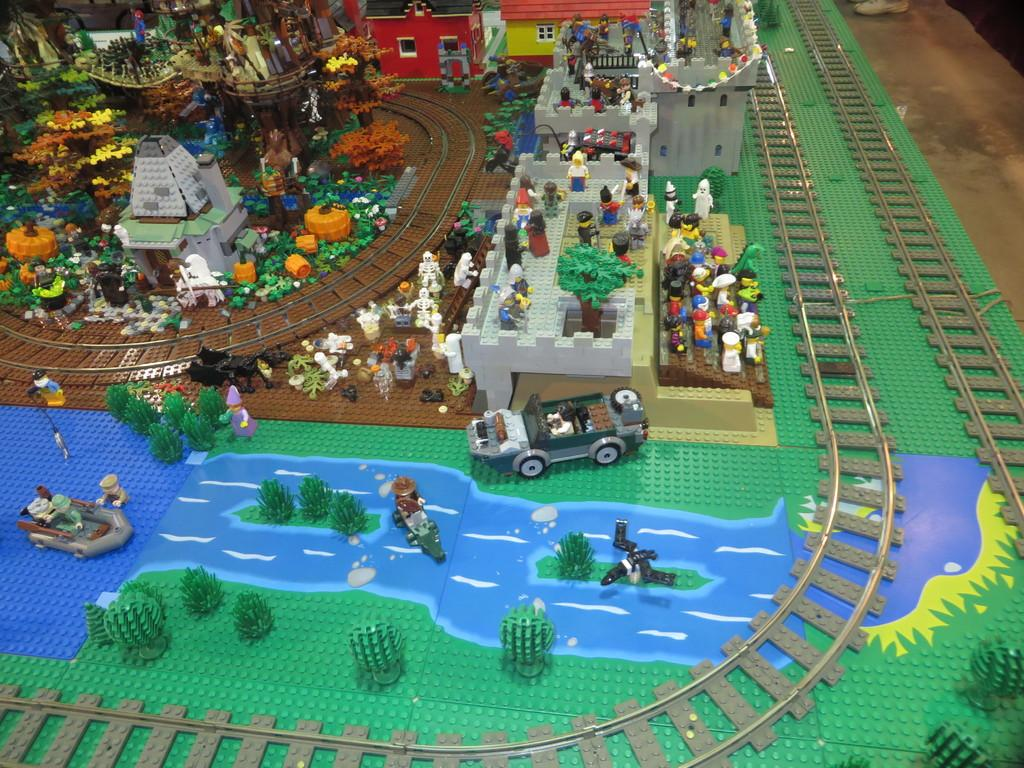What is the main subject of the image? The main subject of the image is lego toys. Where are the lego toys located in the image? The lego toys are in the center of the image. Reasoning: Let's think step by identifying the main subject of the image, which is the lego toys. We then focus on their location in the image, which is in the center. By keeping the questions simple and clear, we can accurately describe the image based on the provided facts. Absurd Question/Answer: What type of farm animals can be seen in the image? There are no farm animals present in the image; it features lego toys. What color is the skin of the person in the image? There is no person present in the image, so it is not possible to determine the color of their skin. 